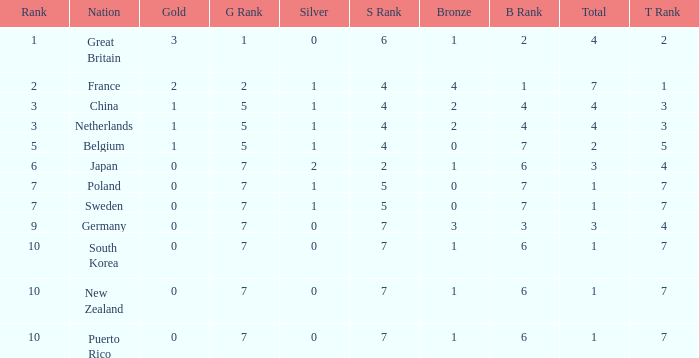What is the smallest number of gold where the total is less than 3 and the silver count is 2? None. 